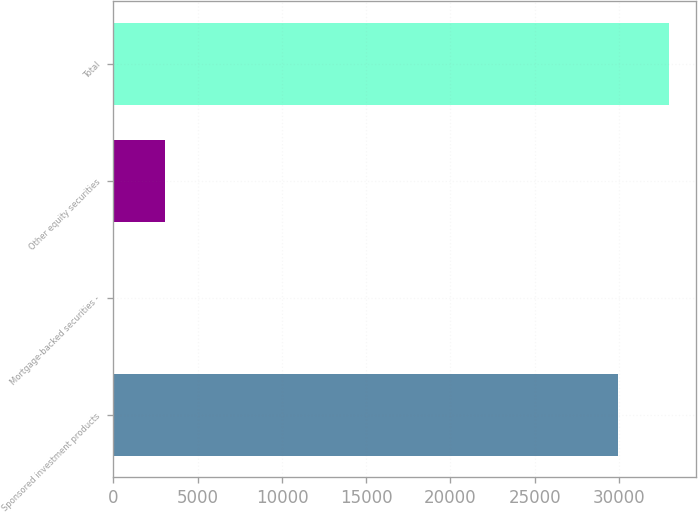<chart> <loc_0><loc_0><loc_500><loc_500><bar_chart><fcel>Sponsored investment products<fcel>Mortgage-backed securities -<fcel>Other equity securities<fcel>Total<nl><fcel>29934<fcel>30<fcel>3044.1<fcel>32948.1<nl></chart> 